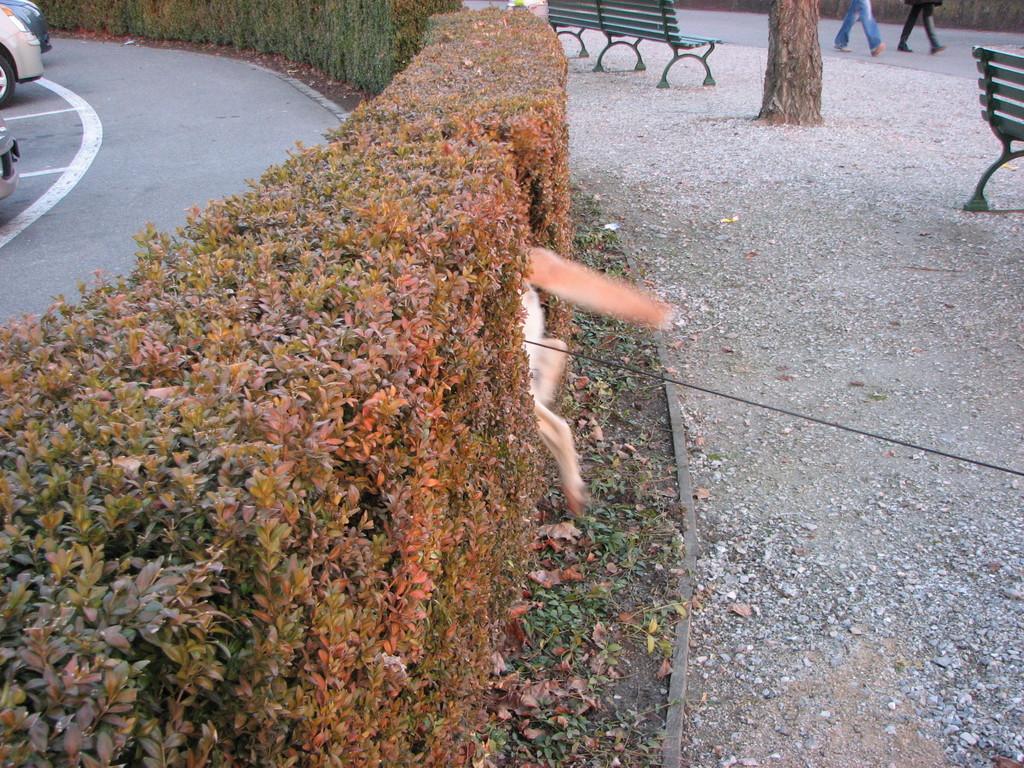In one or two sentences, can you explain what this image depicts? In the foreground of this image, there are plants and also an animal in the plants. At the top left, there are vehicles on the road and at the top right, we can see benches, a trunk and two people walking on the road. 